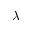<formula> <loc_0><loc_0><loc_500><loc_500>\lambda</formula> 